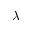<formula> <loc_0><loc_0><loc_500><loc_500>\lambda</formula> 